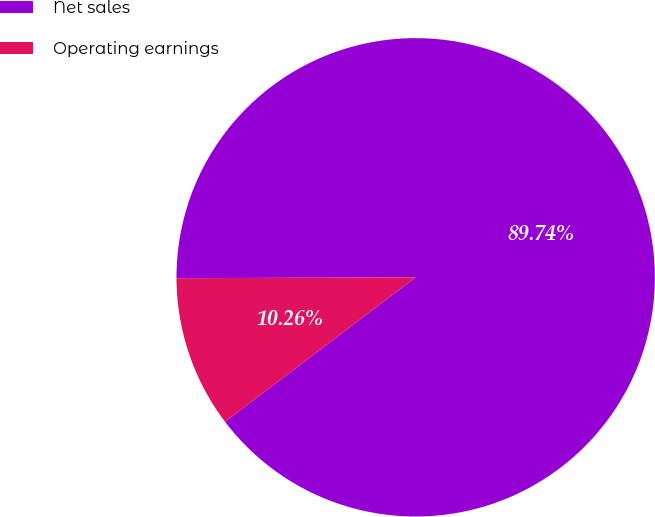Convert chart. <chart><loc_0><loc_0><loc_500><loc_500><pie_chart><fcel>Net sales<fcel>Operating earnings<nl><fcel>89.74%<fcel>10.26%<nl></chart> 